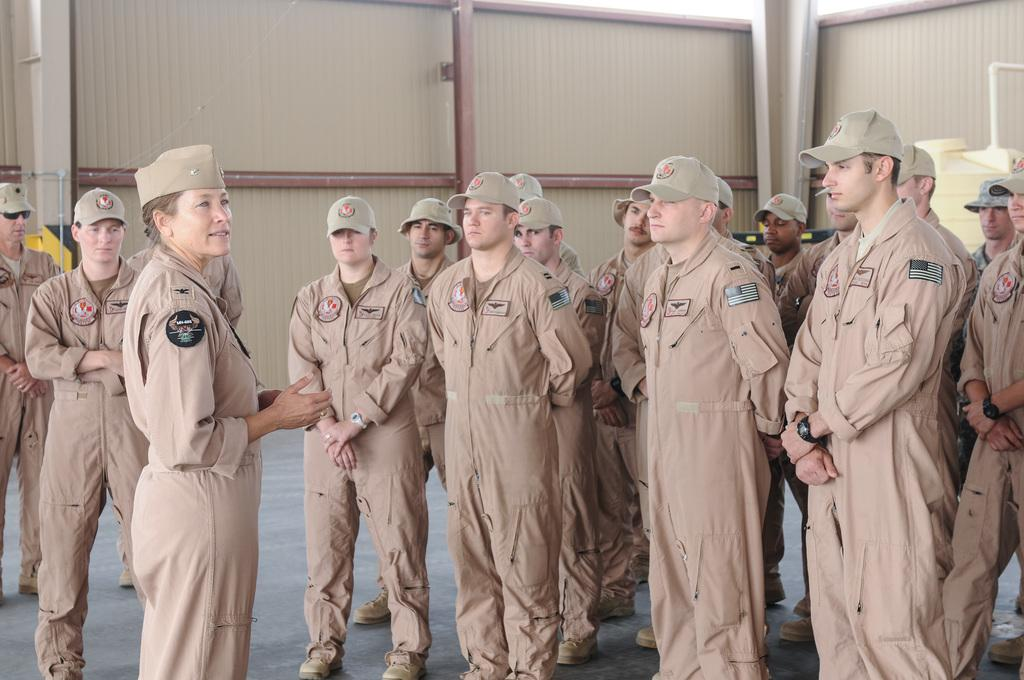How many people are in the image? There are many people in the image. Where are the people located in relation to the wall? The people are standing near a wall. What other object can be seen in the image? There is a water tank in the image. What type of sweater is the giraffe wearing in the image? There is no giraffe or sweater present in the image. 